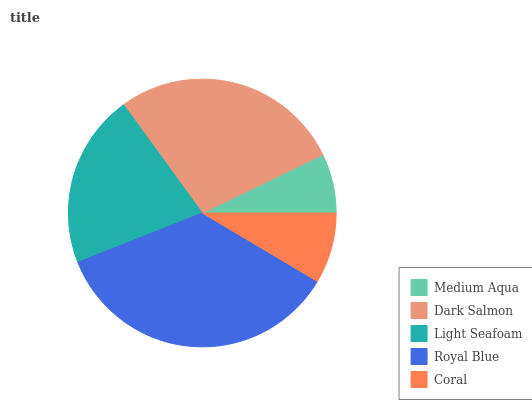Is Medium Aqua the minimum?
Answer yes or no. Yes. Is Royal Blue the maximum?
Answer yes or no. Yes. Is Dark Salmon the minimum?
Answer yes or no. No. Is Dark Salmon the maximum?
Answer yes or no. No. Is Dark Salmon greater than Medium Aqua?
Answer yes or no. Yes. Is Medium Aqua less than Dark Salmon?
Answer yes or no. Yes. Is Medium Aqua greater than Dark Salmon?
Answer yes or no. No. Is Dark Salmon less than Medium Aqua?
Answer yes or no. No. Is Light Seafoam the high median?
Answer yes or no. Yes. Is Light Seafoam the low median?
Answer yes or no. Yes. Is Coral the high median?
Answer yes or no. No. Is Dark Salmon the low median?
Answer yes or no. No. 